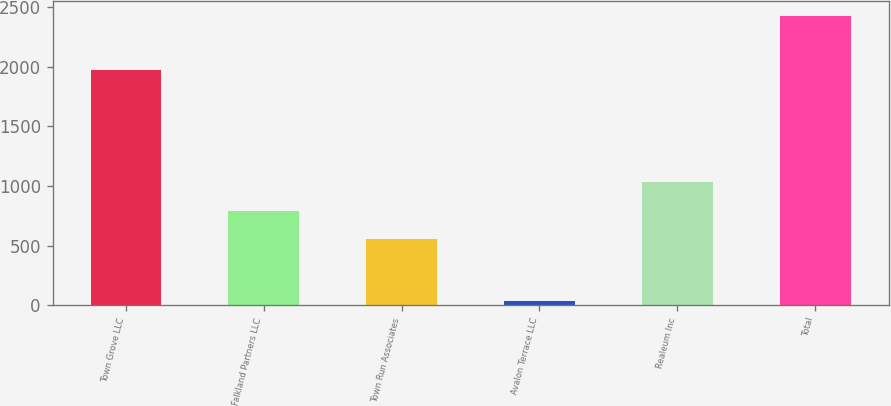<chart> <loc_0><loc_0><loc_500><loc_500><bar_chart><fcel>Town Grove LLC<fcel>Falkland Partners LLC<fcel>Town Run Associates<fcel>Avalon Terrace LLC<fcel>Realeum Inc<fcel>Total<nl><fcel>1977<fcel>794<fcel>555<fcel>38<fcel>1033<fcel>2428<nl></chart> 